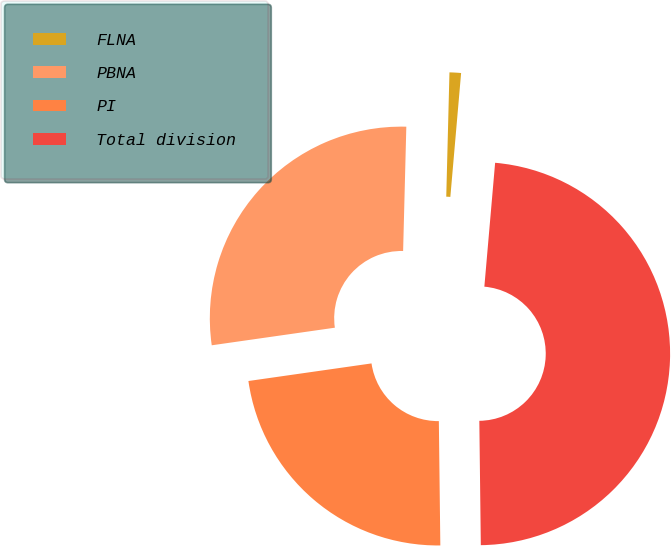Convert chart. <chart><loc_0><loc_0><loc_500><loc_500><pie_chart><fcel>FLNA<fcel>PBNA<fcel>PI<fcel>Total division<nl><fcel>0.97%<fcel>27.67%<fcel>22.93%<fcel>48.43%<nl></chart> 